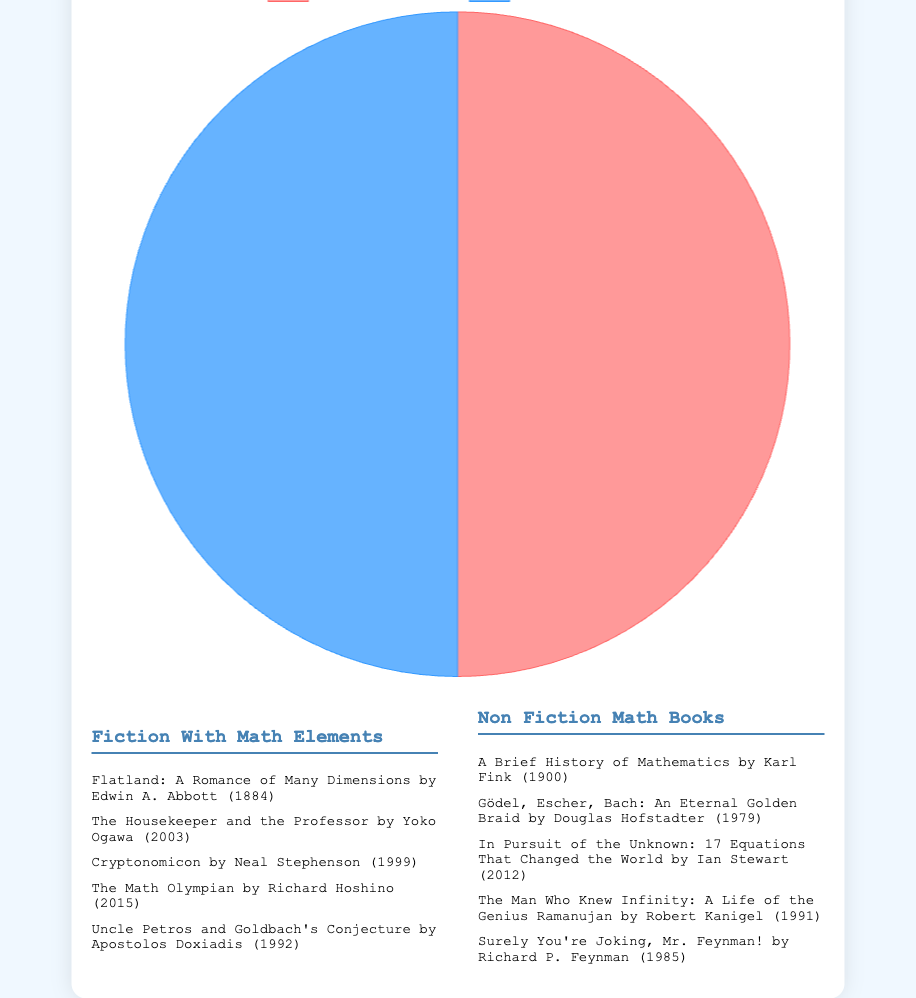What percentage of the recommended books are fiction with math elements? The pie chart shows two categories: Fiction with Math Elements and Non-Fiction Math Books. There are 5 fiction books and 5 non-fiction books, totaling 10 books. The percentage of fiction books is calculated as (5 / 10) * 100 = 50%.
Answer: 50% Which category contains fewer books? The pie chart displays equal-sized segments for both categories, indicating that the number of books in both categories is the same.
Answer: Neither How does the number of fiction books with math elements compare to the number of non-fiction math books? The pie chart shows that both segments representing Fiction with Math Elements and Non-Fiction Math Books are of equal size, indicating that there are an equal number of books in both categories.
Answer: Equal Which genre forms a larger portion of the pie chart: fiction with math elements or non-fiction math books? By observing the pie chart, both genres occupy equal portions of the pie, meaning each category forms an equal part of the chart.
Answer: Neither Is the fraction of non-fiction math books greater than 0.5? The pie chart demonstrates that the Non-Fiction Math Books category occupies half of the chart, making the fraction exactly 0.5, not greater.
Answer: No If three more books were added to the Fiction with Math Elements category, what would be the new percentage of fiction books? Originally, there are 5 fiction books and 5 non-fiction books, totaling 10. Adding 3 more fiction books increases the total to 13 books, with 8 being fiction. The new percentage of fiction is (8 / 13) * 100 ≈ 61.54%.
Answer: 61.54% What would be the new ratio of fiction with math elements to non-fiction math books if 2 more books were added to each category? Initially, both categories have 5 books, resulting in a ratio of 1:1. Adding 2 books to each category makes 7 books per category, keeping the ratio still 1:1.
Answer: 1:1 Are the colors representing Fiction with Math Elements and Non-Fiction Math Books the same? The pie chart uses different colors to represent each category, making it clear that the segments are distinct.
Answer: No 